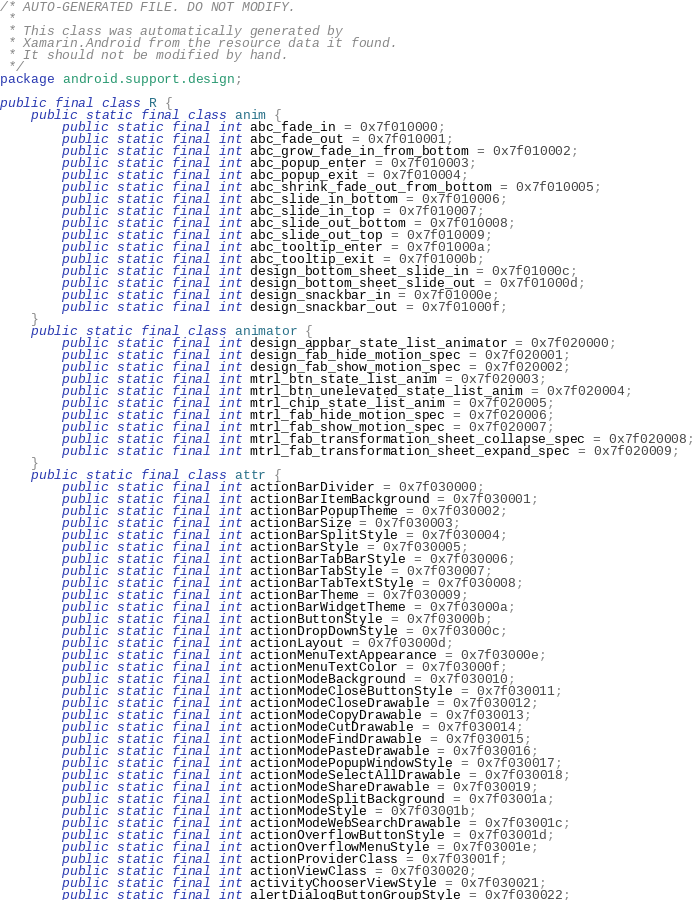Convert code to text. <code><loc_0><loc_0><loc_500><loc_500><_Java_>/* AUTO-GENERATED FILE. DO NOT MODIFY.
 *
 * This class was automatically generated by
 * Xamarin.Android from the resource data it found.
 * It should not be modified by hand.
 */
package android.support.design;

public final class R {
	public static final class anim {
		public static final int abc_fade_in = 0x7f010000;
		public static final int abc_fade_out = 0x7f010001;
		public static final int abc_grow_fade_in_from_bottom = 0x7f010002;
		public static final int abc_popup_enter = 0x7f010003;
		public static final int abc_popup_exit = 0x7f010004;
		public static final int abc_shrink_fade_out_from_bottom = 0x7f010005;
		public static final int abc_slide_in_bottom = 0x7f010006;
		public static final int abc_slide_in_top = 0x7f010007;
		public static final int abc_slide_out_bottom = 0x7f010008;
		public static final int abc_slide_out_top = 0x7f010009;
		public static final int abc_tooltip_enter = 0x7f01000a;
		public static final int abc_tooltip_exit = 0x7f01000b;
		public static final int design_bottom_sheet_slide_in = 0x7f01000c;
		public static final int design_bottom_sheet_slide_out = 0x7f01000d;
		public static final int design_snackbar_in = 0x7f01000e;
		public static final int design_snackbar_out = 0x7f01000f;
	}
	public static final class animator {
		public static final int design_appbar_state_list_animator = 0x7f020000;
		public static final int design_fab_hide_motion_spec = 0x7f020001;
		public static final int design_fab_show_motion_spec = 0x7f020002;
		public static final int mtrl_btn_state_list_anim = 0x7f020003;
		public static final int mtrl_btn_unelevated_state_list_anim = 0x7f020004;
		public static final int mtrl_chip_state_list_anim = 0x7f020005;
		public static final int mtrl_fab_hide_motion_spec = 0x7f020006;
		public static final int mtrl_fab_show_motion_spec = 0x7f020007;
		public static final int mtrl_fab_transformation_sheet_collapse_spec = 0x7f020008;
		public static final int mtrl_fab_transformation_sheet_expand_spec = 0x7f020009;
	}
	public static final class attr {
		public static final int actionBarDivider = 0x7f030000;
		public static final int actionBarItemBackground = 0x7f030001;
		public static final int actionBarPopupTheme = 0x7f030002;
		public static final int actionBarSize = 0x7f030003;
		public static final int actionBarSplitStyle = 0x7f030004;
		public static final int actionBarStyle = 0x7f030005;
		public static final int actionBarTabBarStyle = 0x7f030006;
		public static final int actionBarTabStyle = 0x7f030007;
		public static final int actionBarTabTextStyle = 0x7f030008;
		public static final int actionBarTheme = 0x7f030009;
		public static final int actionBarWidgetTheme = 0x7f03000a;
		public static final int actionButtonStyle = 0x7f03000b;
		public static final int actionDropDownStyle = 0x7f03000c;
		public static final int actionLayout = 0x7f03000d;
		public static final int actionMenuTextAppearance = 0x7f03000e;
		public static final int actionMenuTextColor = 0x7f03000f;
		public static final int actionModeBackground = 0x7f030010;
		public static final int actionModeCloseButtonStyle = 0x7f030011;
		public static final int actionModeCloseDrawable = 0x7f030012;
		public static final int actionModeCopyDrawable = 0x7f030013;
		public static final int actionModeCutDrawable = 0x7f030014;
		public static final int actionModeFindDrawable = 0x7f030015;
		public static final int actionModePasteDrawable = 0x7f030016;
		public static final int actionModePopupWindowStyle = 0x7f030017;
		public static final int actionModeSelectAllDrawable = 0x7f030018;
		public static final int actionModeShareDrawable = 0x7f030019;
		public static final int actionModeSplitBackground = 0x7f03001a;
		public static final int actionModeStyle = 0x7f03001b;
		public static final int actionModeWebSearchDrawable = 0x7f03001c;
		public static final int actionOverflowButtonStyle = 0x7f03001d;
		public static final int actionOverflowMenuStyle = 0x7f03001e;
		public static final int actionProviderClass = 0x7f03001f;
		public static final int actionViewClass = 0x7f030020;
		public static final int activityChooserViewStyle = 0x7f030021;
		public static final int alertDialogButtonGroupStyle = 0x7f030022;</code> 